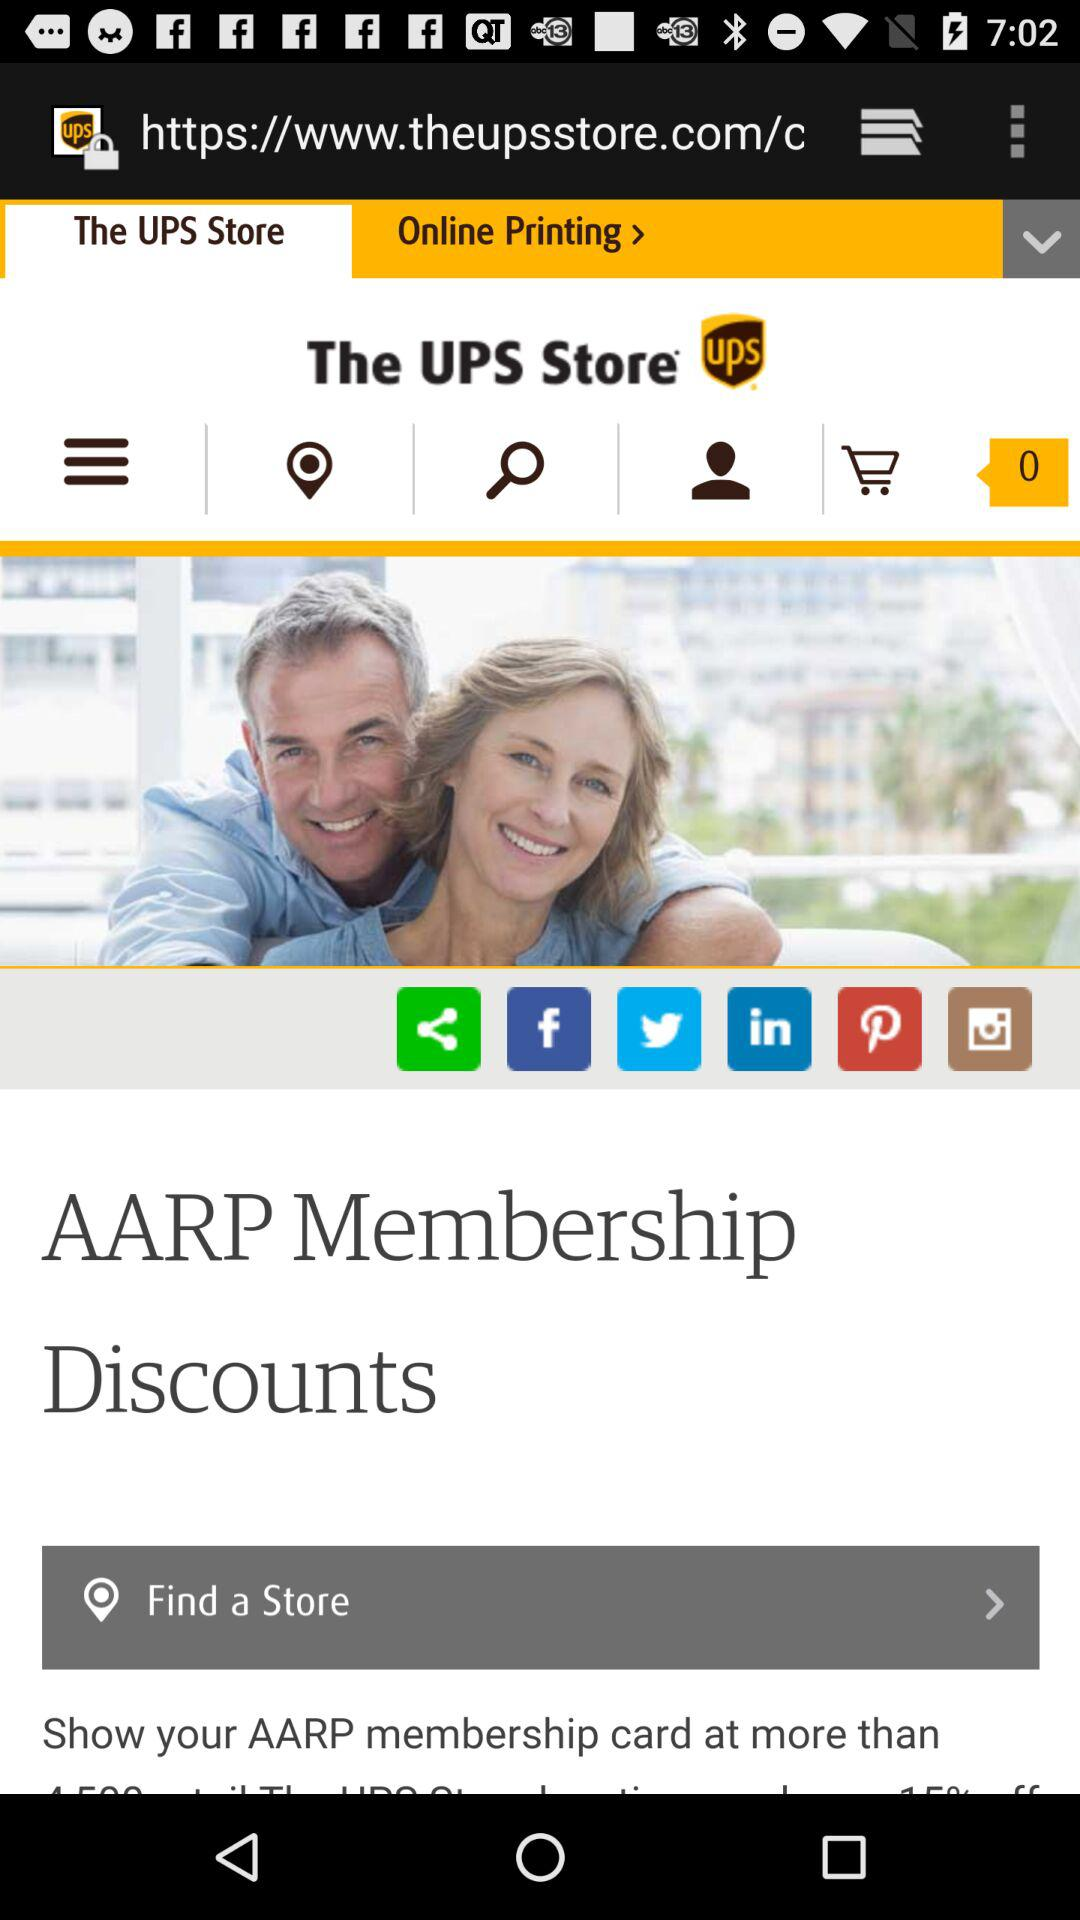What is the application name? The application name is "The UPS Store". 